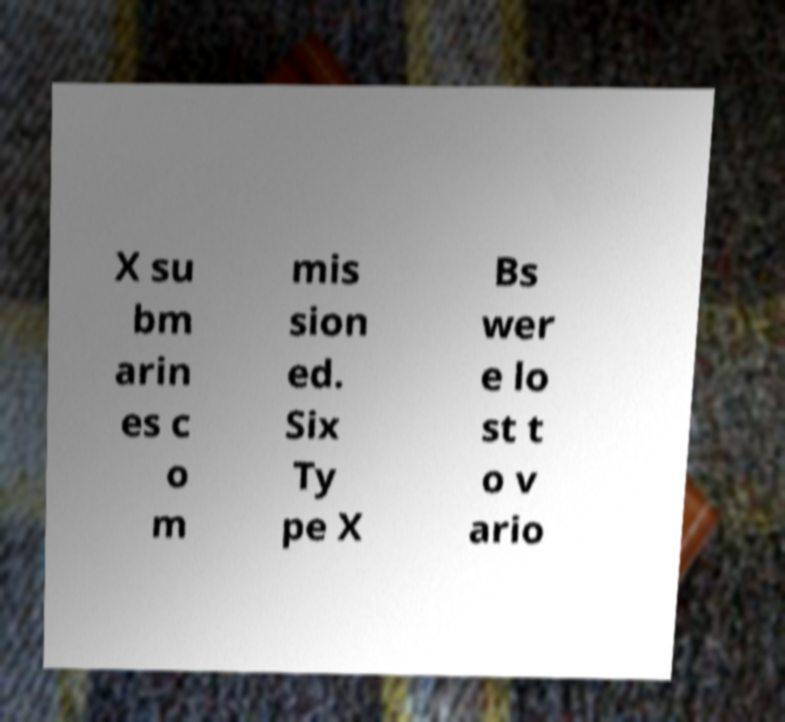I need the written content from this picture converted into text. Can you do that? X su bm arin es c o m mis sion ed. Six Ty pe X Bs wer e lo st t o v ario 